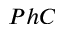<formula> <loc_0><loc_0><loc_500><loc_500>P h C</formula> 